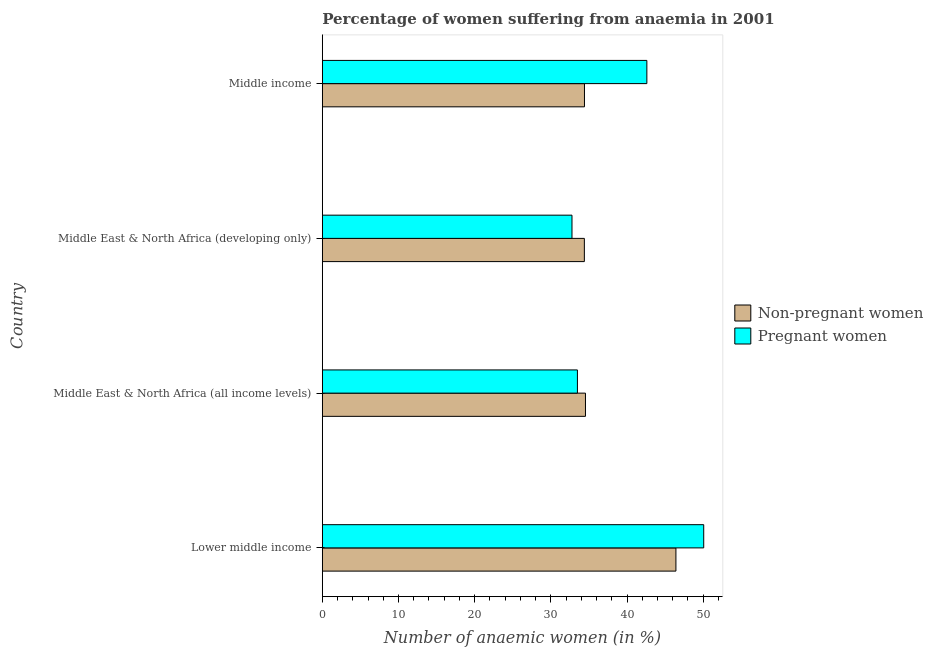Are the number of bars on each tick of the Y-axis equal?
Provide a short and direct response. Yes. How many bars are there on the 1st tick from the top?
Your answer should be compact. 2. What is the label of the 2nd group of bars from the top?
Your answer should be compact. Middle East & North Africa (developing only). What is the percentage of pregnant anaemic women in Middle East & North Africa (developing only)?
Make the answer very short. 32.77. Across all countries, what is the maximum percentage of non-pregnant anaemic women?
Your answer should be very brief. 46.42. Across all countries, what is the minimum percentage of non-pregnant anaemic women?
Offer a terse response. 34.4. In which country was the percentage of pregnant anaemic women maximum?
Give a very brief answer. Lower middle income. In which country was the percentage of non-pregnant anaemic women minimum?
Provide a short and direct response. Middle East & North Africa (developing only). What is the total percentage of pregnant anaemic women in the graph?
Keep it short and to the point. 158.93. What is the difference between the percentage of pregnant anaemic women in Lower middle income and that in Middle East & North Africa (developing only)?
Offer a terse response. 17.29. What is the difference between the percentage of pregnant anaemic women in Middle East & North Africa (all income levels) and the percentage of non-pregnant anaemic women in Middle East & North Africa (developing only)?
Your answer should be compact. -0.91. What is the average percentage of non-pregnant anaemic women per country?
Your response must be concise. 37.44. What is the difference between the percentage of non-pregnant anaemic women and percentage of pregnant anaemic women in Lower middle income?
Give a very brief answer. -3.65. In how many countries, is the percentage of pregnant anaemic women greater than 34 %?
Keep it short and to the point. 2. What is the ratio of the percentage of pregnant anaemic women in Lower middle income to that in Middle income?
Your answer should be compact. 1.18. Is the percentage of non-pregnant anaemic women in Lower middle income less than that in Middle East & North Africa (developing only)?
Your response must be concise. No. What is the difference between the highest and the second highest percentage of non-pregnant anaemic women?
Your response must be concise. 11.88. What is the difference between the highest and the lowest percentage of pregnant anaemic women?
Make the answer very short. 17.29. Is the sum of the percentage of non-pregnant anaemic women in Lower middle income and Middle income greater than the maximum percentage of pregnant anaemic women across all countries?
Provide a succinct answer. Yes. What does the 2nd bar from the top in Middle East & North Africa (all income levels) represents?
Provide a succinct answer. Non-pregnant women. What does the 1st bar from the bottom in Middle East & North Africa (developing only) represents?
Make the answer very short. Non-pregnant women. Are the values on the major ticks of X-axis written in scientific E-notation?
Make the answer very short. No. Does the graph contain any zero values?
Give a very brief answer. No. How many legend labels are there?
Make the answer very short. 2. What is the title of the graph?
Your answer should be very brief. Percentage of women suffering from anaemia in 2001. Does "Attending school" appear as one of the legend labels in the graph?
Provide a short and direct response. No. What is the label or title of the X-axis?
Provide a short and direct response. Number of anaemic women (in %). What is the Number of anaemic women (in %) of Non-pregnant women in Lower middle income?
Ensure brevity in your answer.  46.42. What is the Number of anaemic women (in %) in Pregnant women in Lower middle income?
Offer a terse response. 50.07. What is the Number of anaemic women (in %) of Non-pregnant women in Middle East & North Africa (all income levels)?
Provide a succinct answer. 34.54. What is the Number of anaemic women (in %) in Pregnant women in Middle East & North Africa (all income levels)?
Offer a terse response. 33.49. What is the Number of anaemic women (in %) of Non-pregnant women in Middle East & North Africa (developing only)?
Make the answer very short. 34.4. What is the Number of anaemic women (in %) in Pregnant women in Middle East & North Africa (developing only)?
Provide a short and direct response. 32.77. What is the Number of anaemic women (in %) of Non-pregnant women in Middle income?
Provide a succinct answer. 34.41. What is the Number of anaemic women (in %) in Pregnant women in Middle income?
Your answer should be compact. 42.6. Across all countries, what is the maximum Number of anaemic women (in %) in Non-pregnant women?
Your answer should be compact. 46.42. Across all countries, what is the maximum Number of anaemic women (in %) in Pregnant women?
Make the answer very short. 50.07. Across all countries, what is the minimum Number of anaemic women (in %) in Non-pregnant women?
Provide a succinct answer. 34.4. Across all countries, what is the minimum Number of anaemic women (in %) in Pregnant women?
Offer a terse response. 32.77. What is the total Number of anaemic women (in %) of Non-pregnant women in the graph?
Offer a terse response. 149.77. What is the total Number of anaemic women (in %) of Pregnant women in the graph?
Your answer should be very brief. 158.93. What is the difference between the Number of anaemic women (in %) of Non-pregnant women in Lower middle income and that in Middle East & North Africa (all income levels)?
Your answer should be very brief. 11.87. What is the difference between the Number of anaemic women (in %) of Pregnant women in Lower middle income and that in Middle East & North Africa (all income levels)?
Your answer should be compact. 16.58. What is the difference between the Number of anaemic women (in %) of Non-pregnant women in Lower middle income and that in Middle East & North Africa (developing only)?
Ensure brevity in your answer.  12.02. What is the difference between the Number of anaemic women (in %) of Pregnant women in Lower middle income and that in Middle East & North Africa (developing only)?
Offer a very short reply. 17.29. What is the difference between the Number of anaemic women (in %) of Non-pregnant women in Lower middle income and that in Middle income?
Ensure brevity in your answer.  12.01. What is the difference between the Number of anaemic women (in %) in Pregnant women in Lower middle income and that in Middle income?
Offer a terse response. 7.46. What is the difference between the Number of anaemic women (in %) in Non-pregnant women in Middle East & North Africa (all income levels) and that in Middle East & North Africa (developing only)?
Keep it short and to the point. 0.15. What is the difference between the Number of anaemic women (in %) in Pregnant women in Middle East & North Africa (all income levels) and that in Middle East & North Africa (developing only)?
Make the answer very short. 0.71. What is the difference between the Number of anaemic women (in %) in Non-pregnant women in Middle East & North Africa (all income levels) and that in Middle income?
Your response must be concise. 0.13. What is the difference between the Number of anaemic women (in %) in Pregnant women in Middle East & North Africa (all income levels) and that in Middle income?
Your answer should be very brief. -9.12. What is the difference between the Number of anaemic women (in %) in Non-pregnant women in Middle East & North Africa (developing only) and that in Middle income?
Keep it short and to the point. -0.01. What is the difference between the Number of anaemic women (in %) in Pregnant women in Middle East & North Africa (developing only) and that in Middle income?
Offer a terse response. -9.83. What is the difference between the Number of anaemic women (in %) of Non-pregnant women in Lower middle income and the Number of anaemic women (in %) of Pregnant women in Middle East & North Africa (all income levels)?
Offer a very short reply. 12.93. What is the difference between the Number of anaemic women (in %) of Non-pregnant women in Lower middle income and the Number of anaemic women (in %) of Pregnant women in Middle East & North Africa (developing only)?
Your answer should be very brief. 13.64. What is the difference between the Number of anaemic women (in %) in Non-pregnant women in Lower middle income and the Number of anaemic women (in %) in Pregnant women in Middle income?
Make the answer very short. 3.82. What is the difference between the Number of anaemic women (in %) of Non-pregnant women in Middle East & North Africa (all income levels) and the Number of anaemic women (in %) of Pregnant women in Middle East & North Africa (developing only)?
Offer a very short reply. 1.77. What is the difference between the Number of anaemic women (in %) in Non-pregnant women in Middle East & North Africa (all income levels) and the Number of anaemic women (in %) in Pregnant women in Middle income?
Your response must be concise. -8.06. What is the difference between the Number of anaemic women (in %) of Non-pregnant women in Middle East & North Africa (developing only) and the Number of anaemic women (in %) of Pregnant women in Middle income?
Provide a succinct answer. -8.2. What is the average Number of anaemic women (in %) in Non-pregnant women per country?
Your answer should be very brief. 37.44. What is the average Number of anaemic women (in %) of Pregnant women per country?
Keep it short and to the point. 39.73. What is the difference between the Number of anaemic women (in %) of Non-pregnant women and Number of anaemic women (in %) of Pregnant women in Lower middle income?
Your answer should be very brief. -3.65. What is the difference between the Number of anaemic women (in %) in Non-pregnant women and Number of anaemic women (in %) in Pregnant women in Middle East & North Africa (all income levels)?
Provide a succinct answer. 1.06. What is the difference between the Number of anaemic women (in %) in Non-pregnant women and Number of anaemic women (in %) in Pregnant women in Middle East & North Africa (developing only)?
Keep it short and to the point. 1.62. What is the difference between the Number of anaemic women (in %) of Non-pregnant women and Number of anaemic women (in %) of Pregnant women in Middle income?
Make the answer very short. -8.19. What is the ratio of the Number of anaemic women (in %) of Non-pregnant women in Lower middle income to that in Middle East & North Africa (all income levels)?
Your answer should be compact. 1.34. What is the ratio of the Number of anaemic women (in %) of Pregnant women in Lower middle income to that in Middle East & North Africa (all income levels)?
Offer a very short reply. 1.5. What is the ratio of the Number of anaemic women (in %) in Non-pregnant women in Lower middle income to that in Middle East & North Africa (developing only)?
Give a very brief answer. 1.35. What is the ratio of the Number of anaemic women (in %) in Pregnant women in Lower middle income to that in Middle East & North Africa (developing only)?
Ensure brevity in your answer.  1.53. What is the ratio of the Number of anaemic women (in %) in Non-pregnant women in Lower middle income to that in Middle income?
Provide a succinct answer. 1.35. What is the ratio of the Number of anaemic women (in %) of Pregnant women in Lower middle income to that in Middle income?
Your answer should be compact. 1.18. What is the ratio of the Number of anaemic women (in %) in Non-pregnant women in Middle East & North Africa (all income levels) to that in Middle East & North Africa (developing only)?
Provide a short and direct response. 1. What is the ratio of the Number of anaemic women (in %) in Pregnant women in Middle East & North Africa (all income levels) to that in Middle East & North Africa (developing only)?
Your answer should be compact. 1.02. What is the ratio of the Number of anaemic women (in %) in Pregnant women in Middle East & North Africa (all income levels) to that in Middle income?
Provide a short and direct response. 0.79. What is the ratio of the Number of anaemic women (in %) in Non-pregnant women in Middle East & North Africa (developing only) to that in Middle income?
Your answer should be compact. 1. What is the ratio of the Number of anaemic women (in %) in Pregnant women in Middle East & North Africa (developing only) to that in Middle income?
Your answer should be very brief. 0.77. What is the difference between the highest and the second highest Number of anaemic women (in %) in Non-pregnant women?
Your answer should be compact. 11.87. What is the difference between the highest and the second highest Number of anaemic women (in %) in Pregnant women?
Offer a terse response. 7.46. What is the difference between the highest and the lowest Number of anaemic women (in %) of Non-pregnant women?
Ensure brevity in your answer.  12.02. What is the difference between the highest and the lowest Number of anaemic women (in %) of Pregnant women?
Your answer should be compact. 17.29. 